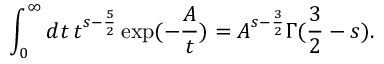Convert formula to latex. <formula><loc_0><loc_0><loc_500><loc_500>\int _ { 0 } ^ { \infty } d t \, t ^ { s - \frac { 5 } { 2 } } \exp ( - \frac { A } { t } ) = A ^ { s - \frac { 3 } { 2 } } \Gamma ( \frac { 3 } { 2 } - s ) .</formula> 